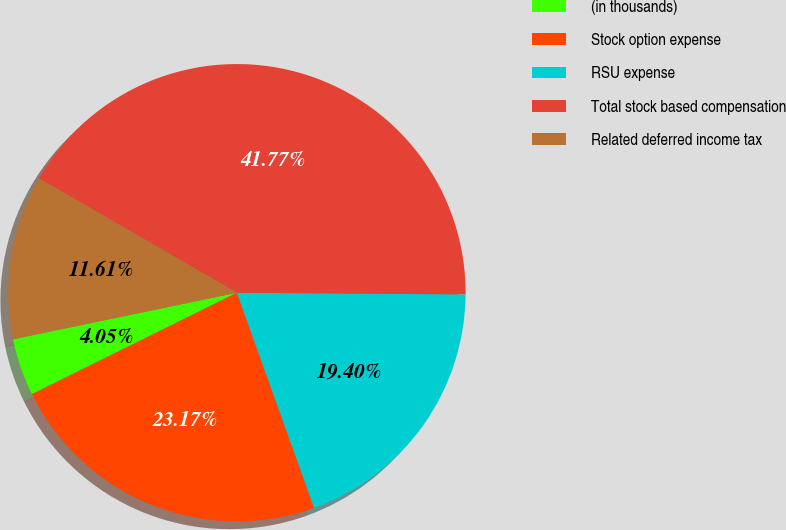Convert chart. <chart><loc_0><loc_0><loc_500><loc_500><pie_chart><fcel>(in thousands)<fcel>Stock option expense<fcel>RSU expense<fcel>Total stock based compensation<fcel>Related deferred income tax<nl><fcel>4.05%<fcel>23.17%<fcel>19.4%<fcel>41.77%<fcel>11.61%<nl></chart> 